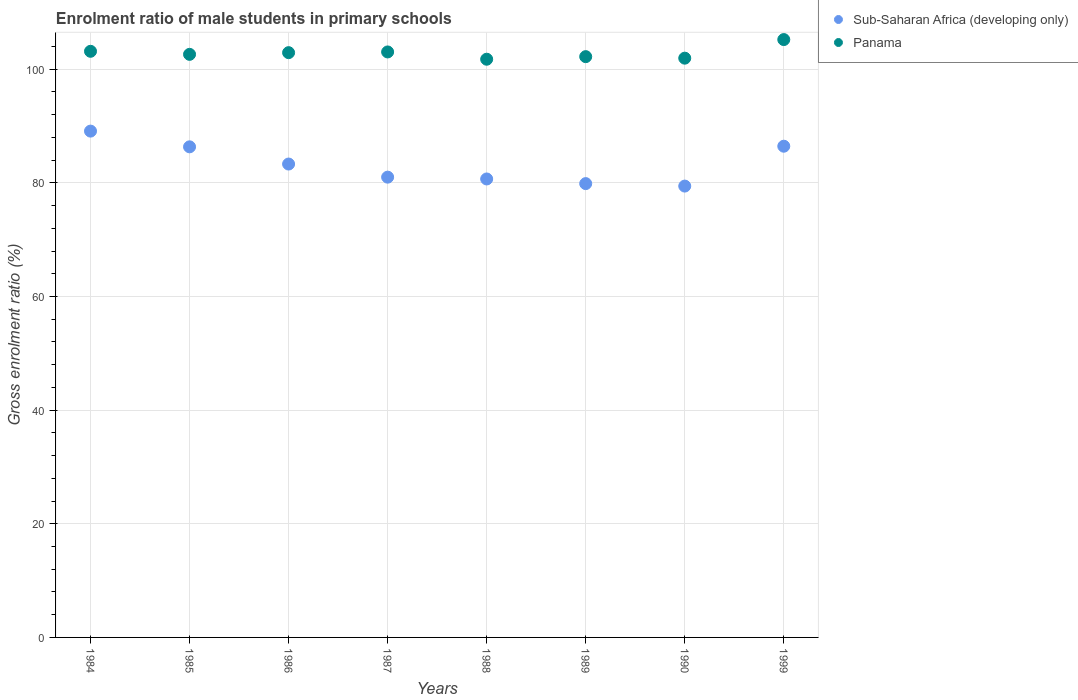Is the number of dotlines equal to the number of legend labels?
Ensure brevity in your answer.  Yes. What is the enrolment ratio of male students in primary schools in Panama in 1987?
Your answer should be very brief. 103.04. Across all years, what is the maximum enrolment ratio of male students in primary schools in Panama?
Provide a short and direct response. 105.22. Across all years, what is the minimum enrolment ratio of male students in primary schools in Panama?
Your answer should be very brief. 101.76. In which year was the enrolment ratio of male students in primary schools in Panama maximum?
Give a very brief answer. 1999. What is the total enrolment ratio of male students in primary schools in Sub-Saharan Africa (developing only) in the graph?
Provide a short and direct response. 666.2. What is the difference between the enrolment ratio of male students in primary schools in Panama in 1984 and that in 1990?
Your answer should be very brief. 1.21. What is the difference between the enrolment ratio of male students in primary schools in Panama in 1988 and the enrolment ratio of male students in primary schools in Sub-Saharan Africa (developing only) in 1989?
Your response must be concise. 21.89. What is the average enrolment ratio of male students in primary schools in Panama per year?
Give a very brief answer. 102.86. In the year 1999, what is the difference between the enrolment ratio of male students in primary schools in Sub-Saharan Africa (developing only) and enrolment ratio of male students in primary schools in Panama?
Offer a very short reply. -18.77. In how many years, is the enrolment ratio of male students in primary schools in Panama greater than 28 %?
Offer a terse response. 8. What is the ratio of the enrolment ratio of male students in primary schools in Panama in 1989 to that in 1999?
Offer a very short reply. 0.97. What is the difference between the highest and the second highest enrolment ratio of male students in primary schools in Sub-Saharan Africa (developing only)?
Provide a succinct answer. 2.66. What is the difference between the highest and the lowest enrolment ratio of male students in primary schools in Sub-Saharan Africa (developing only)?
Your answer should be compact. 9.67. In how many years, is the enrolment ratio of male students in primary schools in Panama greater than the average enrolment ratio of male students in primary schools in Panama taken over all years?
Offer a terse response. 4. Is the sum of the enrolment ratio of male students in primary schools in Sub-Saharan Africa (developing only) in 1985 and 1990 greater than the maximum enrolment ratio of male students in primary schools in Panama across all years?
Your response must be concise. Yes. Does the enrolment ratio of male students in primary schools in Sub-Saharan Africa (developing only) monotonically increase over the years?
Your answer should be compact. No. Does the graph contain any zero values?
Ensure brevity in your answer.  No. Does the graph contain grids?
Your answer should be compact. Yes. Where does the legend appear in the graph?
Your answer should be compact. Top right. What is the title of the graph?
Ensure brevity in your answer.  Enrolment ratio of male students in primary schools. Does "Cote d'Ivoire" appear as one of the legend labels in the graph?
Your answer should be very brief. No. What is the label or title of the X-axis?
Ensure brevity in your answer.  Years. What is the label or title of the Y-axis?
Your answer should be compact. Gross enrolment ratio (%). What is the Gross enrolment ratio (%) of Sub-Saharan Africa (developing only) in 1984?
Your answer should be compact. 89.11. What is the Gross enrolment ratio (%) of Panama in 1984?
Provide a short and direct response. 103.15. What is the Gross enrolment ratio (%) of Sub-Saharan Africa (developing only) in 1985?
Your answer should be very brief. 86.34. What is the Gross enrolment ratio (%) of Panama in 1985?
Offer a terse response. 102.62. What is the Gross enrolment ratio (%) in Sub-Saharan Africa (developing only) in 1986?
Make the answer very short. 83.31. What is the Gross enrolment ratio (%) in Panama in 1986?
Provide a short and direct response. 102.91. What is the Gross enrolment ratio (%) of Sub-Saharan Africa (developing only) in 1987?
Provide a succinct answer. 81. What is the Gross enrolment ratio (%) in Panama in 1987?
Give a very brief answer. 103.04. What is the Gross enrolment ratio (%) in Sub-Saharan Africa (developing only) in 1988?
Your answer should be very brief. 80.68. What is the Gross enrolment ratio (%) of Panama in 1988?
Ensure brevity in your answer.  101.76. What is the Gross enrolment ratio (%) of Sub-Saharan Africa (developing only) in 1989?
Offer a terse response. 79.87. What is the Gross enrolment ratio (%) in Panama in 1989?
Your response must be concise. 102.21. What is the Gross enrolment ratio (%) in Sub-Saharan Africa (developing only) in 1990?
Offer a terse response. 79.43. What is the Gross enrolment ratio (%) in Panama in 1990?
Keep it short and to the point. 101.94. What is the Gross enrolment ratio (%) of Sub-Saharan Africa (developing only) in 1999?
Your response must be concise. 86.45. What is the Gross enrolment ratio (%) of Panama in 1999?
Ensure brevity in your answer.  105.22. Across all years, what is the maximum Gross enrolment ratio (%) of Sub-Saharan Africa (developing only)?
Provide a succinct answer. 89.11. Across all years, what is the maximum Gross enrolment ratio (%) in Panama?
Ensure brevity in your answer.  105.22. Across all years, what is the minimum Gross enrolment ratio (%) in Sub-Saharan Africa (developing only)?
Offer a very short reply. 79.43. Across all years, what is the minimum Gross enrolment ratio (%) in Panama?
Ensure brevity in your answer.  101.76. What is the total Gross enrolment ratio (%) of Sub-Saharan Africa (developing only) in the graph?
Your response must be concise. 666.2. What is the total Gross enrolment ratio (%) in Panama in the graph?
Provide a short and direct response. 822.86. What is the difference between the Gross enrolment ratio (%) of Sub-Saharan Africa (developing only) in 1984 and that in 1985?
Provide a succinct answer. 2.77. What is the difference between the Gross enrolment ratio (%) in Panama in 1984 and that in 1985?
Give a very brief answer. 0.54. What is the difference between the Gross enrolment ratio (%) of Sub-Saharan Africa (developing only) in 1984 and that in 1986?
Provide a short and direct response. 5.79. What is the difference between the Gross enrolment ratio (%) in Panama in 1984 and that in 1986?
Give a very brief answer. 0.24. What is the difference between the Gross enrolment ratio (%) in Sub-Saharan Africa (developing only) in 1984 and that in 1987?
Make the answer very short. 8.1. What is the difference between the Gross enrolment ratio (%) in Panama in 1984 and that in 1987?
Ensure brevity in your answer.  0.11. What is the difference between the Gross enrolment ratio (%) of Sub-Saharan Africa (developing only) in 1984 and that in 1988?
Offer a very short reply. 8.42. What is the difference between the Gross enrolment ratio (%) of Panama in 1984 and that in 1988?
Offer a very short reply. 1.39. What is the difference between the Gross enrolment ratio (%) in Sub-Saharan Africa (developing only) in 1984 and that in 1989?
Offer a terse response. 9.24. What is the difference between the Gross enrolment ratio (%) in Panama in 1984 and that in 1989?
Provide a short and direct response. 0.94. What is the difference between the Gross enrolment ratio (%) in Sub-Saharan Africa (developing only) in 1984 and that in 1990?
Ensure brevity in your answer.  9.67. What is the difference between the Gross enrolment ratio (%) of Panama in 1984 and that in 1990?
Your answer should be compact. 1.21. What is the difference between the Gross enrolment ratio (%) in Sub-Saharan Africa (developing only) in 1984 and that in 1999?
Give a very brief answer. 2.66. What is the difference between the Gross enrolment ratio (%) in Panama in 1984 and that in 1999?
Keep it short and to the point. -2.06. What is the difference between the Gross enrolment ratio (%) of Sub-Saharan Africa (developing only) in 1985 and that in 1986?
Provide a succinct answer. 3.03. What is the difference between the Gross enrolment ratio (%) in Panama in 1985 and that in 1986?
Keep it short and to the point. -0.3. What is the difference between the Gross enrolment ratio (%) in Sub-Saharan Africa (developing only) in 1985 and that in 1987?
Ensure brevity in your answer.  5.34. What is the difference between the Gross enrolment ratio (%) in Panama in 1985 and that in 1987?
Ensure brevity in your answer.  -0.42. What is the difference between the Gross enrolment ratio (%) in Sub-Saharan Africa (developing only) in 1985 and that in 1988?
Your answer should be very brief. 5.66. What is the difference between the Gross enrolment ratio (%) of Panama in 1985 and that in 1988?
Provide a short and direct response. 0.86. What is the difference between the Gross enrolment ratio (%) of Sub-Saharan Africa (developing only) in 1985 and that in 1989?
Ensure brevity in your answer.  6.47. What is the difference between the Gross enrolment ratio (%) in Panama in 1985 and that in 1989?
Your answer should be very brief. 0.4. What is the difference between the Gross enrolment ratio (%) of Sub-Saharan Africa (developing only) in 1985 and that in 1990?
Provide a succinct answer. 6.91. What is the difference between the Gross enrolment ratio (%) in Panama in 1985 and that in 1990?
Your answer should be very brief. 0.67. What is the difference between the Gross enrolment ratio (%) in Sub-Saharan Africa (developing only) in 1985 and that in 1999?
Provide a succinct answer. -0.11. What is the difference between the Gross enrolment ratio (%) of Panama in 1985 and that in 1999?
Make the answer very short. -2.6. What is the difference between the Gross enrolment ratio (%) in Sub-Saharan Africa (developing only) in 1986 and that in 1987?
Your answer should be very brief. 2.31. What is the difference between the Gross enrolment ratio (%) in Panama in 1986 and that in 1987?
Ensure brevity in your answer.  -0.13. What is the difference between the Gross enrolment ratio (%) of Sub-Saharan Africa (developing only) in 1986 and that in 1988?
Your answer should be very brief. 2.63. What is the difference between the Gross enrolment ratio (%) in Panama in 1986 and that in 1988?
Ensure brevity in your answer.  1.16. What is the difference between the Gross enrolment ratio (%) of Sub-Saharan Africa (developing only) in 1986 and that in 1989?
Give a very brief answer. 3.45. What is the difference between the Gross enrolment ratio (%) in Panama in 1986 and that in 1989?
Your response must be concise. 0.7. What is the difference between the Gross enrolment ratio (%) of Sub-Saharan Africa (developing only) in 1986 and that in 1990?
Make the answer very short. 3.88. What is the difference between the Gross enrolment ratio (%) of Panama in 1986 and that in 1990?
Your response must be concise. 0.97. What is the difference between the Gross enrolment ratio (%) in Sub-Saharan Africa (developing only) in 1986 and that in 1999?
Provide a short and direct response. -3.14. What is the difference between the Gross enrolment ratio (%) of Panama in 1986 and that in 1999?
Give a very brief answer. -2.3. What is the difference between the Gross enrolment ratio (%) of Sub-Saharan Africa (developing only) in 1987 and that in 1988?
Your answer should be very brief. 0.32. What is the difference between the Gross enrolment ratio (%) in Panama in 1987 and that in 1988?
Offer a terse response. 1.28. What is the difference between the Gross enrolment ratio (%) of Sub-Saharan Africa (developing only) in 1987 and that in 1989?
Your answer should be very brief. 1.14. What is the difference between the Gross enrolment ratio (%) in Panama in 1987 and that in 1989?
Your answer should be very brief. 0.83. What is the difference between the Gross enrolment ratio (%) of Sub-Saharan Africa (developing only) in 1987 and that in 1990?
Offer a terse response. 1.57. What is the difference between the Gross enrolment ratio (%) in Panama in 1987 and that in 1990?
Your answer should be compact. 1.09. What is the difference between the Gross enrolment ratio (%) of Sub-Saharan Africa (developing only) in 1987 and that in 1999?
Your response must be concise. -5.44. What is the difference between the Gross enrolment ratio (%) of Panama in 1987 and that in 1999?
Give a very brief answer. -2.18. What is the difference between the Gross enrolment ratio (%) in Sub-Saharan Africa (developing only) in 1988 and that in 1989?
Make the answer very short. 0.82. What is the difference between the Gross enrolment ratio (%) of Panama in 1988 and that in 1989?
Your answer should be compact. -0.45. What is the difference between the Gross enrolment ratio (%) of Sub-Saharan Africa (developing only) in 1988 and that in 1990?
Make the answer very short. 1.25. What is the difference between the Gross enrolment ratio (%) of Panama in 1988 and that in 1990?
Offer a very short reply. -0.19. What is the difference between the Gross enrolment ratio (%) in Sub-Saharan Africa (developing only) in 1988 and that in 1999?
Your response must be concise. -5.76. What is the difference between the Gross enrolment ratio (%) in Panama in 1988 and that in 1999?
Keep it short and to the point. -3.46. What is the difference between the Gross enrolment ratio (%) in Sub-Saharan Africa (developing only) in 1989 and that in 1990?
Keep it short and to the point. 0.43. What is the difference between the Gross enrolment ratio (%) of Panama in 1989 and that in 1990?
Your answer should be very brief. 0.27. What is the difference between the Gross enrolment ratio (%) of Sub-Saharan Africa (developing only) in 1989 and that in 1999?
Provide a succinct answer. -6.58. What is the difference between the Gross enrolment ratio (%) in Panama in 1989 and that in 1999?
Your answer should be very brief. -3. What is the difference between the Gross enrolment ratio (%) of Sub-Saharan Africa (developing only) in 1990 and that in 1999?
Offer a very short reply. -7.02. What is the difference between the Gross enrolment ratio (%) of Panama in 1990 and that in 1999?
Your answer should be very brief. -3.27. What is the difference between the Gross enrolment ratio (%) of Sub-Saharan Africa (developing only) in 1984 and the Gross enrolment ratio (%) of Panama in 1985?
Keep it short and to the point. -13.51. What is the difference between the Gross enrolment ratio (%) in Sub-Saharan Africa (developing only) in 1984 and the Gross enrolment ratio (%) in Panama in 1986?
Give a very brief answer. -13.81. What is the difference between the Gross enrolment ratio (%) of Sub-Saharan Africa (developing only) in 1984 and the Gross enrolment ratio (%) of Panama in 1987?
Provide a succinct answer. -13.93. What is the difference between the Gross enrolment ratio (%) in Sub-Saharan Africa (developing only) in 1984 and the Gross enrolment ratio (%) in Panama in 1988?
Make the answer very short. -12.65. What is the difference between the Gross enrolment ratio (%) in Sub-Saharan Africa (developing only) in 1984 and the Gross enrolment ratio (%) in Panama in 1989?
Provide a short and direct response. -13.11. What is the difference between the Gross enrolment ratio (%) in Sub-Saharan Africa (developing only) in 1984 and the Gross enrolment ratio (%) in Panama in 1990?
Your answer should be very brief. -12.84. What is the difference between the Gross enrolment ratio (%) of Sub-Saharan Africa (developing only) in 1984 and the Gross enrolment ratio (%) of Panama in 1999?
Provide a short and direct response. -16.11. What is the difference between the Gross enrolment ratio (%) of Sub-Saharan Africa (developing only) in 1985 and the Gross enrolment ratio (%) of Panama in 1986?
Provide a short and direct response. -16.57. What is the difference between the Gross enrolment ratio (%) in Sub-Saharan Africa (developing only) in 1985 and the Gross enrolment ratio (%) in Panama in 1987?
Give a very brief answer. -16.7. What is the difference between the Gross enrolment ratio (%) in Sub-Saharan Africa (developing only) in 1985 and the Gross enrolment ratio (%) in Panama in 1988?
Keep it short and to the point. -15.42. What is the difference between the Gross enrolment ratio (%) in Sub-Saharan Africa (developing only) in 1985 and the Gross enrolment ratio (%) in Panama in 1989?
Keep it short and to the point. -15.87. What is the difference between the Gross enrolment ratio (%) of Sub-Saharan Africa (developing only) in 1985 and the Gross enrolment ratio (%) of Panama in 1990?
Make the answer very short. -15.6. What is the difference between the Gross enrolment ratio (%) of Sub-Saharan Africa (developing only) in 1985 and the Gross enrolment ratio (%) of Panama in 1999?
Give a very brief answer. -18.88. What is the difference between the Gross enrolment ratio (%) of Sub-Saharan Africa (developing only) in 1986 and the Gross enrolment ratio (%) of Panama in 1987?
Ensure brevity in your answer.  -19.73. What is the difference between the Gross enrolment ratio (%) of Sub-Saharan Africa (developing only) in 1986 and the Gross enrolment ratio (%) of Panama in 1988?
Offer a terse response. -18.45. What is the difference between the Gross enrolment ratio (%) in Sub-Saharan Africa (developing only) in 1986 and the Gross enrolment ratio (%) in Panama in 1989?
Your answer should be compact. -18.9. What is the difference between the Gross enrolment ratio (%) of Sub-Saharan Africa (developing only) in 1986 and the Gross enrolment ratio (%) of Panama in 1990?
Provide a short and direct response. -18.63. What is the difference between the Gross enrolment ratio (%) in Sub-Saharan Africa (developing only) in 1986 and the Gross enrolment ratio (%) in Panama in 1999?
Your answer should be very brief. -21.9. What is the difference between the Gross enrolment ratio (%) in Sub-Saharan Africa (developing only) in 1987 and the Gross enrolment ratio (%) in Panama in 1988?
Offer a terse response. -20.75. What is the difference between the Gross enrolment ratio (%) of Sub-Saharan Africa (developing only) in 1987 and the Gross enrolment ratio (%) of Panama in 1989?
Give a very brief answer. -21.21. What is the difference between the Gross enrolment ratio (%) of Sub-Saharan Africa (developing only) in 1987 and the Gross enrolment ratio (%) of Panama in 1990?
Your response must be concise. -20.94. What is the difference between the Gross enrolment ratio (%) of Sub-Saharan Africa (developing only) in 1987 and the Gross enrolment ratio (%) of Panama in 1999?
Offer a very short reply. -24.21. What is the difference between the Gross enrolment ratio (%) in Sub-Saharan Africa (developing only) in 1988 and the Gross enrolment ratio (%) in Panama in 1989?
Your response must be concise. -21.53. What is the difference between the Gross enrolment ratio (%) in Sub-Saharan Africa (developing only) in 1988 and the Gross enrolment ratio (%) in Panama in 1990?
Provide a short and direct response. -21.26. What is the difference between the Gross enrolment ratio (%) of Sub-Saharan Africa (developing only) in 1988 and the Gross enrolment ratio (%) of Panama in 1999?
Provide a short and direct response. -24.53. What is the difference between the Gross enrolment ratio (%) of Sub-Saharan Africa (developing only) in 1989 and the Gross enrolment ratio (%) of Panama in 1990?
Your answer should be very brief. -22.08. What is the difference between the Gross enrolment ratio (%) in Sub-Saharan Africa (developing only) in 1989 and the Gross enrolment ratio (%) in Panama in 1999?
Give a very brief answer. -25.35. What is the difference between the Gross enrolment ratio (%) in Sub-Saharan Africa (developing only) in 1990 and the Gross enrolment ratio (%) in Panama in 1999?
Make the answer very short. -25.78. What is the average Gross enrolment ratio (%) of Sub-Saharan Africa (developing only) per year?
Offer a terse response. 83.27. What is the average Gross enrolment ratio (%) in Panama per year?
Your answer should be very brief. 102.86. In the year 1984, what is the difference between the Gross enrolment ratio (%) of Sub-Saharan Africa (developing only) and Gross enrolment ratio (%) of Panama?
Keep it short and to the point. -14.05. In the year 1985, what is the difference between the Gross enrolment ratio (%) of Sub-Saharan Africa (developing only) and Gross enrolment ratio (%) of Panama?
Your response must be concise. -16.28. In the year 1986, what is the difference between the Gross enrolment ratio (%) in Sub-Saharan Africa (developing only) and Gross enrolment ratio (%) in Panama?
Provide a succinct answer. -19.6. In the year 1987, what is the difference between the Gross enrolment ratio (%) of Sub-Saharan Africa (developing only) and Gross enrolment ratio (%) of Panama?
Offer a terse response. -22.04. In the year 1988, what is the difference between the Gross enrolment ratio (%) of Sub-Saharan Africa (developing only) and Gross enrolment ratio (%) of Panama?
Your answer should be compact. -21.07. In the year 1989, what is the difference between the Gross enrolment ratio (%) in Sub-Saharan Africa (developing only) and Gross enrolment ratio (%) in Panama?
Give a very brief answer. -22.34. In the year 1990, what is the difference between the Gross enrolment ratio (%) of Sub-Saharan Africa (developing only) and Gross enrolment ratio (%) of Panama?
Your answer should be very brief. -22.51. In the year 1999, what is the difference between the Gross enrolment ratio (%) of Sub-Saharan Africa (developing only) and Gross enrolment ratio (%) of Panama?
Your answer should be compact. -18.77. What is the ratio of the Gross enrolment ratio (%) of Sub-Saharan Africa (developing only) in 1984 to that in 1985?
Your answer should be very brief. 1.03. What is the ratio of the Gross enrolment ratio (%) of Panama in 1984 to that in 1985?
Make the answer very short. 1.01. What is the ratio of the Gross enrolment ratio (%) of Sub-Saharan Africa (developing only) in 1984 to that in 1986?
Keep it short and to the point. 1.07. What is the ratio of the Gross enrolment ratio (%) in Panama in 1984 to that in 1987?
Give a very brief answer. 1. What is the ratio of the Gross enrolment ratio (%) of Sub-Saharan Africa (developing only) in 1984 to that in 1988?
Give a very brief answer. 1.1. What is the ratio of the Gross enrolment ratio (%) of Panama in 1984 to that in 1988?
Your answer should be very brief. 1.01. What is the ratio of the Gross enrolment ratio (%) in Sub-Saharan Africa (developing only) in 1984 to that in 1989?
Ensure brevity in your answer.  1.12. What is the ratio of the Gross enrolment ratio (%) in Panama in 1984 to that in 1989?
Your answer should be compact. 1.01. What is the ratio of the Gross enrolment ratio (%) of Sub-Saharan Africa (developing only) in 1984 to that in 1990?
Make the answer very short. 1.12. What is the ratio of the Gross enrolment ratio (%) of Panama in 1984 to that in 1990?
Offer a terse response. 1.01. What is the ratio of the Gross enrolment ratio (%) of Sub-Saharan Africa (developing only) in 1984 to that in 1999?
Offer a very short reply. 1.03. What is the ratio of the Gross enrolment ratio (%) in Panama in 1984 to that in 1999?
Provide a short and direct response. 0.98. What is the ratio of the Gross enrolment ratio (%) in Sub-Saharan Africa (developing only) in 1985 to that in 1986?
Give a very brief answer. 1.04. What is the ratio of the Gross enrolment ratio (%) in Panama in 1985 to that in 1986?
Your answer should be very brief. 1. What is the ratio of the Gross enrolment ratio (%) of Sub-Saharan Africa (developing only) in 1985 to that in 1987?
Your answer should be very brief. 1.07. What is the ratio of the Gross enrolment ratio (%) of Sub-Saharan Africa (developing only) in 1985 to that in 1988?
Your answer should be very brief. 1.07. What is the ratio of the Gross enrolment ratio (%) in Panama in 1985 to that in 1988?
Provide a succinct answer. 1.01. What is the ratio of the Gross enrolment ratio (%) of Sub-Saharan Africa (developing only) in 1985 to that in 1989?
Provide a short and direct response. 1.08. What is the ratio of the Gross enrolment ratio (%) in Panama in 1985 to that in 1989?
Provide a succinct answer. 1. What is the ratio of the Gross enrolment ratio (%) in Sub-Saharan Africa (developing only) in 1985 to that in 1990?
Your response must be concise. 1.09. What is the ratio of the Gross enrolment ratio (%) in Panama in 1985 to that in 1990?
Keep it short and to the point. 1.01. What is the ratio of the Gross enrolment ratio (%) of Sub-Saharan Africa (developing only) in 1985 to that in 1999?
Give a very brief answer. 1. What is the ratio of the Gross enrolment ratio (%) of Panama in 1985 to that in 1999?
Make the answer very short. 0.98. What is the ratio of the Gross enrolment ratio (%) in Sub-Saharan Africa (developing only) in 1986 to that in 1987?
Make the answer very short. 1.03. What is the ratio of the Gross enrolment ratio (%) of Sub-Saharan Africa (developing only) in 1986 to that in 1988?
Your response must be concise. 1.03. What is the ratio of the Gross enrolment ratio (%) in Panama in 1986 to that in 1988?
Give a very brief answer. 1.01. What is the ratio of the Gross enrolment ratio (%) of Sub-Saharan Africa (developing only) in 1986 to that in 1989?
Provide a short and direct response. 1.04. What is the ratio of the Gross enrolment ratio (%) in Sub-Saharan Africa (developing only) in 1986 to that in 1990?
Keep it short and to the point. 1.05. What is the ratio of the Gross enrolment ratio (%) of Panama in 1986 to that in 1990?
Keep it short and to the point. 1.01. What is the ratio of the Gross enrolment ratio (%) of Sub-Saharan Africa (developing only) in 1986 to that in 1999?
Give a very brief answer. 0.96. What is the ratio of the Gross enrolment ratio (%) in Panama in 1986 to that in 1999?
Your response must be concise. 0.98. What is the ratio of the Gross enrolment ratio (%) in Sub-Saharan Africa (developing only) in 1987 to that in 1988?
Give a very brief answer. 1. What is the ratio of the Gross enrolment ratio (%) in Panama in 1987 to that in 1988?
Keep it short and to the point. 1.01. What is the ratio of the Gross enrolment ratio (%) of Sub-Saharan Africa (developing only) in 1987 to that in 1989?
Your answer should be very brief. 1.01. What is the ratio of the Gross enrolment ratio (%) of Sub-Saharan Africa (developing only) in 1987 to that in 1990?
Provide a succinct answer. 1.02. What is the ratio of the Gross enrolment ratio (%) of Panama in 1987 to that in 1990?
Ensure brevity in your answer.  1.01. What is the ratio of the Gross enrolment ratio (%) of Sub-Saharan Africa (developing only) in 1987 to that in 1999?
Your response must be concise. 0.94. What is the ratio of the Gross enrolment ratio (%) in Panama in 1987 to that in 1999?
Your answer should be compact. 0.98. What is the ratio of the Gross enrolment ratio (%) of Sub-Saharan Africa (developing only) in 1988 to that in 1989?
Your answer should be very brief. 1.01. What is the ratio of the Gross enrolment ratio (%) of Panama in 1988 to that in 1989?
Provide a short and direct response. 1. What is the ratio of the Gross enrolment ratio (%) of Sub-Saharan Africa (developing only) in 1988 to that in 1990?
Keep it short and to the point. 1.02. What is the ratio of the Gross enrolment ratio (%) of Panama in 1988 to that in 1990?
Offer a terse response. 1. What is the ratio of the Gross enrolment ratio (%) in Panama in 1988 to that in 1999?
Your answer should be very brief. 0.97. What is the ratio of the Gross enrolment ratio (%) of Panama in 1989 to that in 1990?
Make the answer very short. 1. What is the ratio of the Gross enrolment ratio (%) in Sub-Saharan Africa (developing only) in 1989 to that in 1999?
Keep it short and to the point. 0.92. What is the ratio of the Gross enrolment ratio (%) in Panama in 1989 to that in 1999?
Make the answer very short. 0.97. What is the ratio of the Gross enrolment ratio (%) of Sub-Saharan Africa (developing only) in 1990 to that in 1999?
Your answer should be very brief. 0.92. What is the ratio of the Gross enrolment ratio (%) of Panama in 1990 to that in 1999?
Make the answer very short. 0.97. What is the difference between the highest and the second highest Gross enrolment ratio (%) of Sub-Saharan Africa (developing only)?
Ensure brevity in your answer.  2.66. What is the difference between the highest and the second highest Gross enrolment ratio (%) in Panama?
Your answer should be compact. 2.06. What is the difference between the highest and the lowest Gross enrolment ratio (%) of Sub-Saharan Africa (developing only)?
Provide a succinct answer. 9.67. What is the difference between the highest and the lowest Gross enrolment ratio (%) in Panama?
Ensure brevity in your answer.  3.46. 